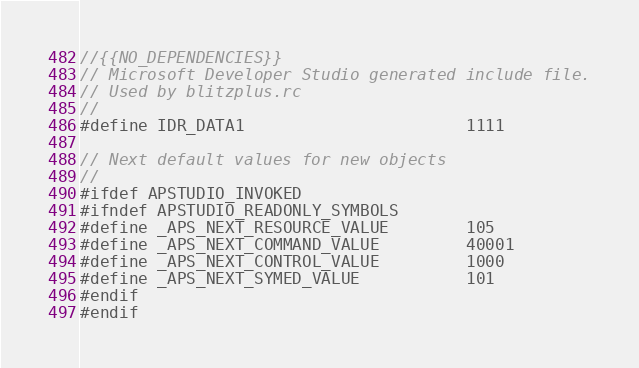<code> <loc_0><loc_0><loc_500><loc_500><_C_>//{{NO_DEPENDENCIES}}
// Microsoft Developer Studio generated include file.
// Used by blitzplus.rc
//
#define IDR_DATA1                       1111

// Next default values for new objects
// 
#ifdef APSTUDIO_INVOKED
#ifndef APSTUDIO_READONLY_SYMBOLS
#define _APS_NEXT_RESOURCE_VALUE        105
#define _APS_NEXT_COMMAND_VALUE         40001
#define _APS_NEXT_CONTROL_VALUE         1000
#define _APS_NEXT_SYMED_VALUE           101
#endif
#endif
</code> 